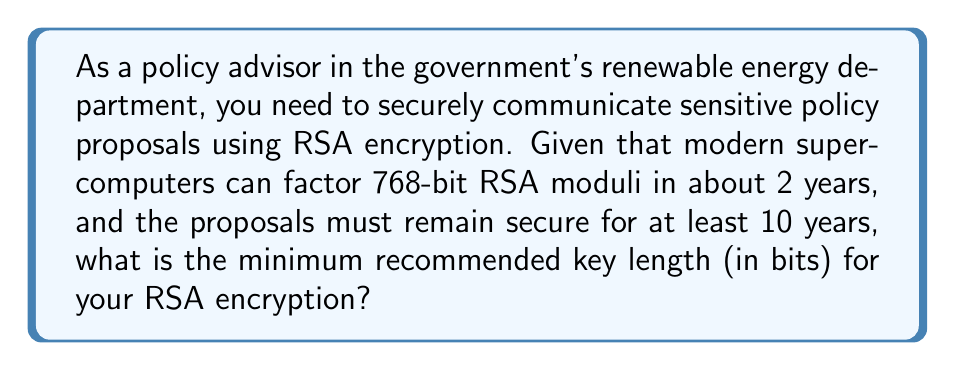Could you help me with this problem? To determine the appropriate key length for RSA encryption, we need to consider the following steps:

1. Understand the current state of factoring capabilities:
   - 768-bit RSA moduli can be factored in about 2 years by modern supercomputers.

2. Calculate the rate of improvement in factoring capabilities:
   - Moore's Law suggests that computing power doubles approximately every 18 months.
   - In 10 years, there are 6.67 periods of 18 months (10 years / 1.5 years).
   - Improvement factor: $2^{6.67} \approx 101.59$

3. Calculate the equivalent difficulty for 10 years of security:
   - We need a key that would take $101.59 \times 2$ years $\approx 203.18$ years to factor with current technology.

4. Estimate the required key length:
   - The difficulty of factoring increases exponentially with key length.
   - A good estimate is that doubling the key length increases factoring time by a factor of $2^4 = 16$.
   - We need to find how many times we need to double 768 bits to reach 203.18 years.
   - Solve for $x$: $16^x \times 2 = 203.18$
   - $x \approx 2.37$

5. Calculate the minimum key length:
   - Minimum key length $= 768 \times 2^{2.37} \approx 3938$ bits

6. Round up to the nearest standard key size:
   - Standard RSA key sizes are typically multiples of 1024 bits.
   - The next standard size above 3938 bits is 4096 bits.

Therefore, the minimum recommended key length for secure communication of policy proposals using RSA encryption for the next 10 years is 4096 bits.
Answer: 4096 bits 